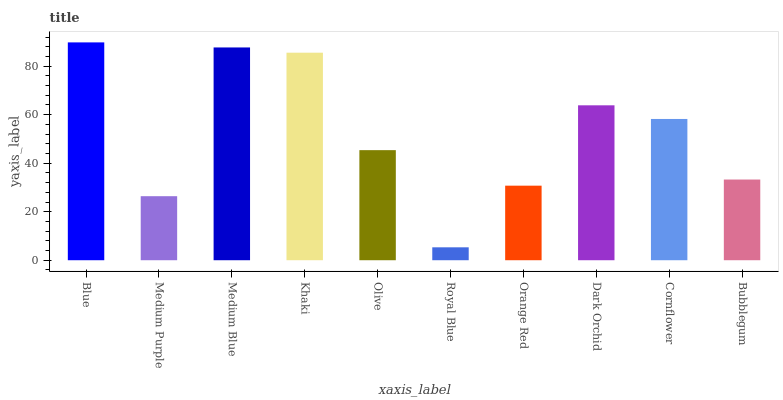Is Royal Blue the minimum?
Answer yes or no. Yes. Is Blue the maximum?
Answer yes or no. Yes. Is Medium Purple the minimum?
Answer yes or no. No. Is Medium Purple the maximum?
Answer yes or no. No. Is Blue greater than Medium Purple?
Answer yes or no. Yes. Is Medium Purple less than Blue?
Answer yes or no. Yes. Is Medium Purple greater than Blue?
Answer yes or no. No. Is Blue less than Medium Purple?
Answer yes or no. No. Is Cornflower the high median?
Answer yes or no. Yes. Is Olive the low median?
Answer yes or no. Yes. Is Olive the high median?
Answer yes or no. No. Is Medium Purple the low median?
Answer yes or no. No. 